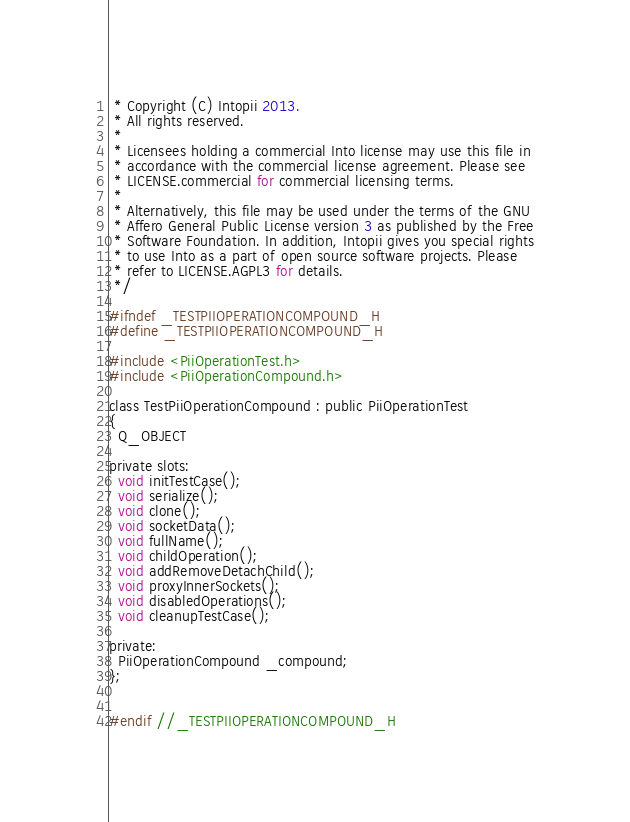Convert code to text. <code><loc_0><loc_0><loc_500><loc_500><_C_> * Copyright (C) Intopii 2013.
 * All rights reserved.
 *
 * Licensees holding a commercial Into license may use this file in
 * accordance with the commercial license agreement. Please see
 * LICENSE.commercial for commercial licensing terms.
 *
 * Alternatively, this file may be used under the terms of the GNU
 * Affero General Public License version 3 as published by the Free
 * Software Foundation. In addition, Intopii gives you special rights
 * to use Into as a part of open source software projects. Please
 * refer to LICENSE.AGPL3 for details.
 */

#ifndef _TESTPIIOPERATIONCOMPOUND_H
#define _TESTPIIOPERATIONCOMPOUND_H

#include <PiiOperationTest.h>
#include <PiiOperationCompound.h>

class TestPiiOperationCompound : public PiiOperationTest
{
  Q_OBJECT

private slots:
  void initTestCase();
  void serialize();
  void clone();
  void socketData();
  void fullName();
  void childOperation();
  void addRemoveDetachChild();
  void proxyInnerSockets();
  void disabledOperations();
  void cleanupTestCase();

private:
  PiiOperationCompound _compound;
};


#endif //_TESTPIIOPERATIONCOMPOUND_H
</code> 